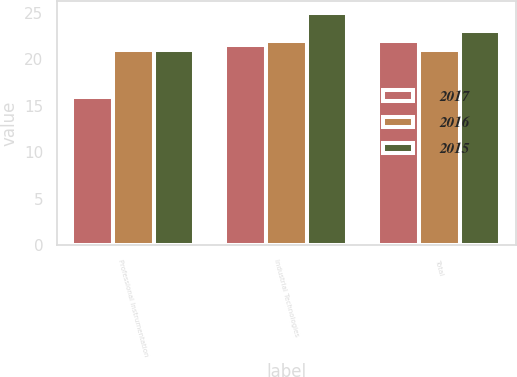Convert chart. <chart><loc_0><loc_0><loc_500><loc_500><stacked_bar_chart><ecel><fcel>Professional Instrumentation<fcel>Industrial Technologies<fcel>Total<nl><fcel>2017<fcel>16<fcel>21.5<fcel>22<nl><fcel>2016<fcel>21<fcel>22<fcel>21<nl><fcel>2015<fcel>21<fcel>25<fcel>23<nl></chart> 